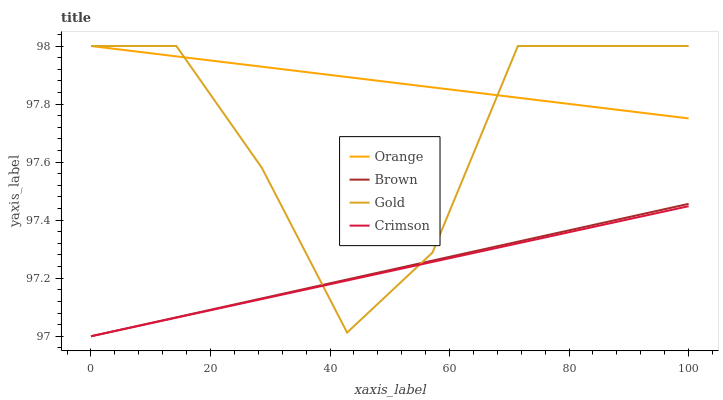Does Crimson have the minimum area under the curve?
Answer yes or no. Yes. Does Orange have the maximum area under the curve?
Answer yes or no. Yes. Does Brown have the minimum area under the curve?
Answer yes or no. No. Does Brown have the maximum area under the curve?
Answer yes or no. No. Is Orange the smoothest?
Answer yes or no. Yes. Is Gold the roughest?
Answer yes or no. Yes. Is Brown the smoothest?
Answer yes or no. No. Is Brown the roughest?
Answer yes or no. No. Does Brown have the lowest value?
Answer yes or no. Yes. Does Gold have the lowest value?
Answer yes or no. No. Does Gold have the highest value?
Answer yes or no. Yes. Does Brown have the highest value?
Answer yes or no. No. Is Crimson less than Orange?
Answer yes or no. Yes. Is Orange greater than Crimson?
Answer yes or no. Yes. Does Crimson intersect Brown?
Answer yes or no. Yes. Is Crimson less than Brown?
Answer yes or no. No. Is Crimson greater than Brown?
Answer yes or no. No. Does Crimson intersect Orange?
Answer yes or no. No. 